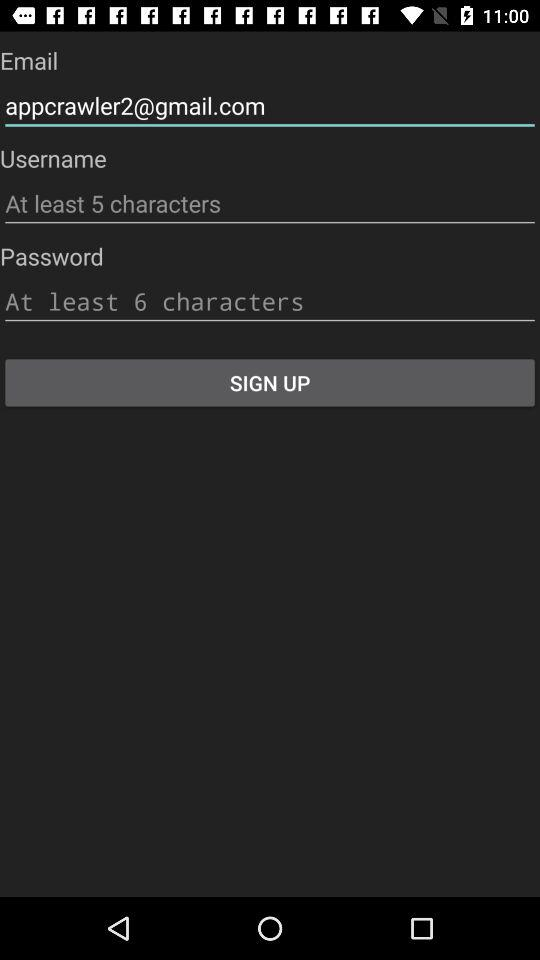How many characters must be used in a username? There are at least 5 characters that must be used in a username. 